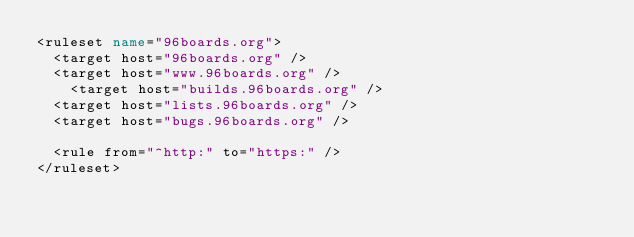<code> <loc_0><loc_0><loc_500><loc_500><_XML_><ruleset name="96boards.org">
	<target host="96boards.org" />
	<target host="www.96boards.org" />
  	<target host="builds.96boards.org" />
	<target host="lists.96boards.org" />
	<target host="bugs.96boards.org" />

	<rule from="^http:" to="https:" />
</ruleset>
</code> 